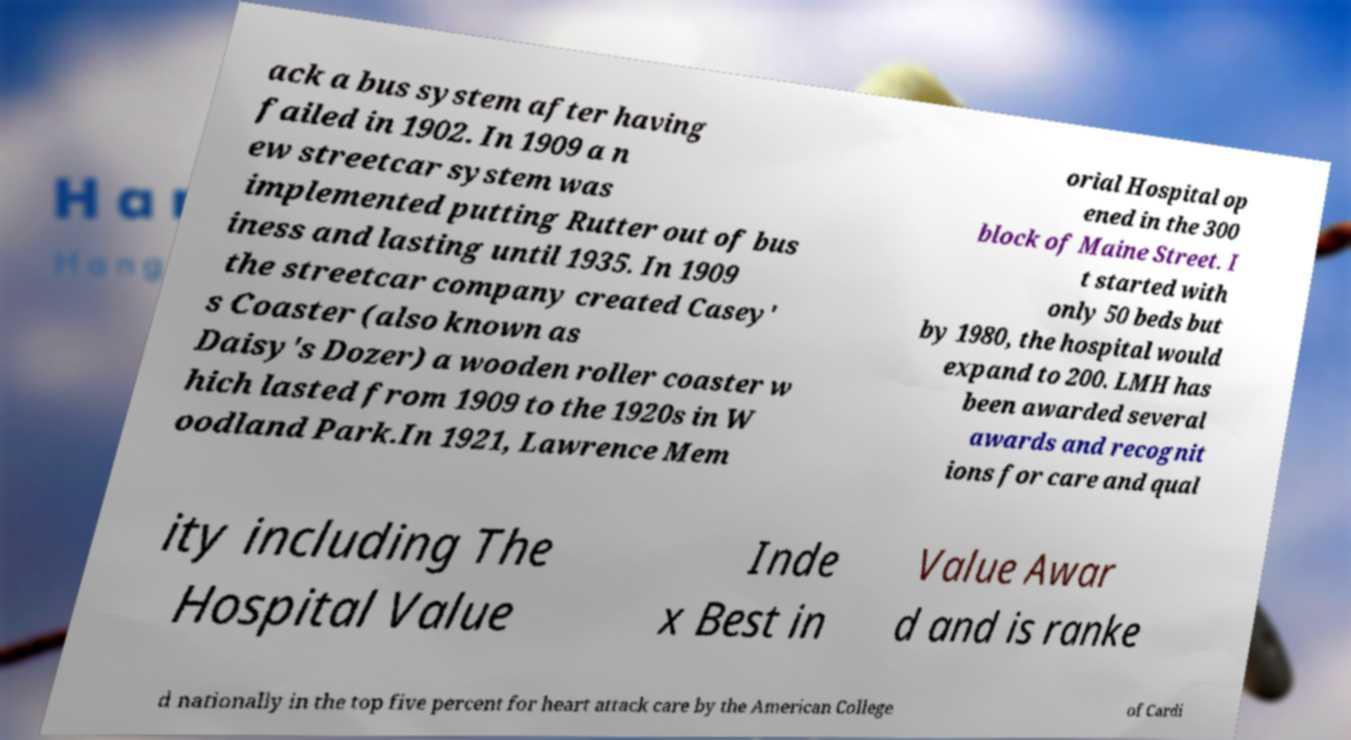Could you assist in decoding the text presented in this image and type it out clearly? ack a bus system after having failed in 1902. In 1909 a n ew streetcar system was implemented putting Rutter out of bus iness and lasting until 1935. In 1909 the streetcar company created Casey' s Coaster (also known as Daisy's Dozer) a wooden roller coaster w hich lasted from 1909 to the 1920s in W oodland Park.In 1921, Lawrence Mem orial Hospital op ened in the 300 block of Maine Street. I t started with only 50 beds but by 1980, the hospital would expand to 200. LMH has been awarded several awards and recognit ions for care and qual ity including The Hospital Value Inde x Best in Value Awar d and is ranke d nationally in the top five percent for heart attack care by the American College of Cardi 